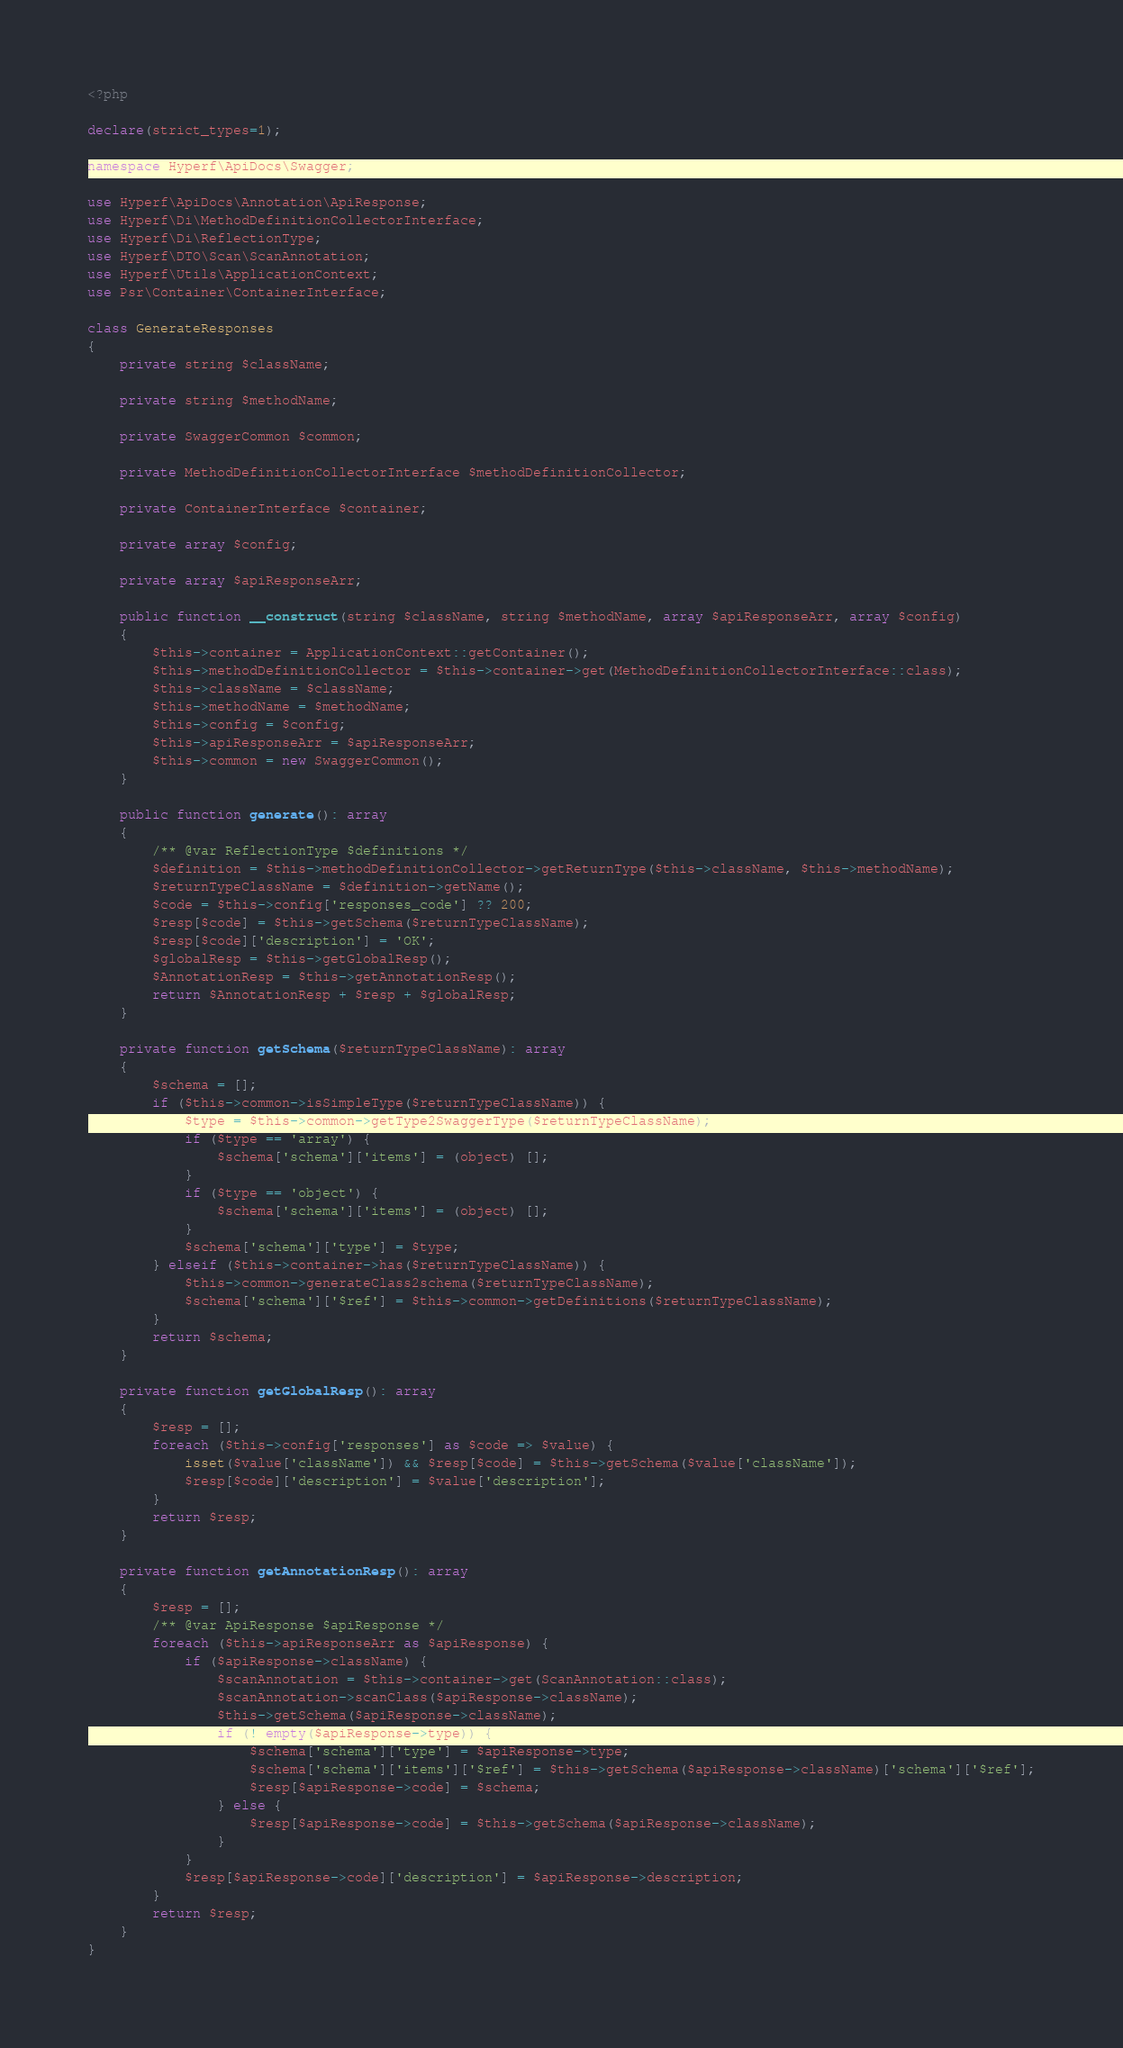<code> <loc_0><loc_0><loc_500><loc_500><_PHP_><?php

declare(strict_types=1);

namespace Hyperf\ApiDocs\Swagger;

use Hyperf\ApiDocs\Annotation\ApiResponse;
use Hyperf\Di\MethodDefinitionCollectorInterface;
use Hyperf\Di\ReflectionType;
use Hyperf\DTO\Scan\ScanAnnotation;
use Hyperf\Utils\ApplicationContext;
use Psr\Container\ContainerInterface;

class GenerateResponses
{
    private string $className;

    private string $methodName;

    private SwaggerCommon $common;

    private MethodDefinitionCollectorInterface $methodDefinitionCollector;

    private ContainerInterface $container;

    private array $config;

    private array $apiResponseArr;

    public function __construct(string $className, string $methodName, array $apiResponseArr, array $config)
    {
        $this->container = ApplicationContext::getContainer();
        $this->methodDefinitionCollector = $this->container->get(MethodDefinitionCollectorInterface::class);
        $this->className = $className;
        $this->methodName = $methodName;
        $this->config = $config;
        $this->apiResponseArr = $apiResponseArr;
        $this->common = new SwaggerCommon();
    }

    public function generate(): array
    {
        /** @var ReflectionType $definitions */
        $definition = $this->methodDefinitionCollector->getReturnType($this->className, $this->methodName);
        $returnTypeClassName = $definition->getName();
        $code = $this->config['responses_code'] ?? 200;
        $resp[$code] = $this->getSchema($returnTypeClassName);
        $resp[$code]['description'] = 'OK';
        $globalResp = $this->getGlobalResp();
        $AnnotationResp = $this->getAnnotationResp();
        return $AnnotationResp + $resp + $globalResp;
    }

    private function getSchema($returnTypeClassName): array
    {
        $schema = [];
        if ($this->common->isSimpleType($returnTypeClassName)) {
            $type = $this->common->getType2SwaggerType($returnTypeClassName);
            if ($type == 'array') {
                $schema['schema']['items'] = (object) [];
            }
            if ($type == 'object') {
                $schema['schema']['items'] = (object) [];
            }
            $schema['schema']['type'] = $type;
        } elseif ($this->container->has($returnTypeClassName)) {
            $this->common->generateClass2schema($returnTypeClassName);
            $schema['schema']['$ref'] = $this->common->getDefinitions($returnTypeClassName);
        }
        return $schema;
    }

    private function getGlobalResp(): array
    {
        $resp = [];
        foreach ($this->config['responses'] as $code => $value) {
            isset($value['className']) && $resp[$code] = $this->getSchema($value['className']);
            $resp[$code]['description'] = $value['description'];
        }
        return $resp;
    }

    private function getAnnotationResp(): array
    {
        $resp = [];
        /** @var ApiResponse $apiResponse */
        foreach ($this->apiResponseArr as $apiResponse) {
            if ($apiResponse->className) {
                $scanAnnotation = $this->container->get(ScanAnnotation::class);
                $scanAnnotation->scanClass($apiResponse->className);
                $this->getSchema($apiResponse->className);
                if (! empty($apiResponse->type)) {
                    $schema['schema']['type'] = $apiResponse->type;
                    $schema['schema']['items']['$ref'] = $this->getSchema($apiResponse->className)['schema']['$ref'];
                    $resp[$apiResponse->code] = $schema;
                } else {
                    $resp[$apiResponse->code] = $this->getSchema($apiResponse->className);
                }
            }
            $resp[$apiResponse->code]['description'] = $apiResponse->description;
        }
        return $resp;
    }
}
</code> 